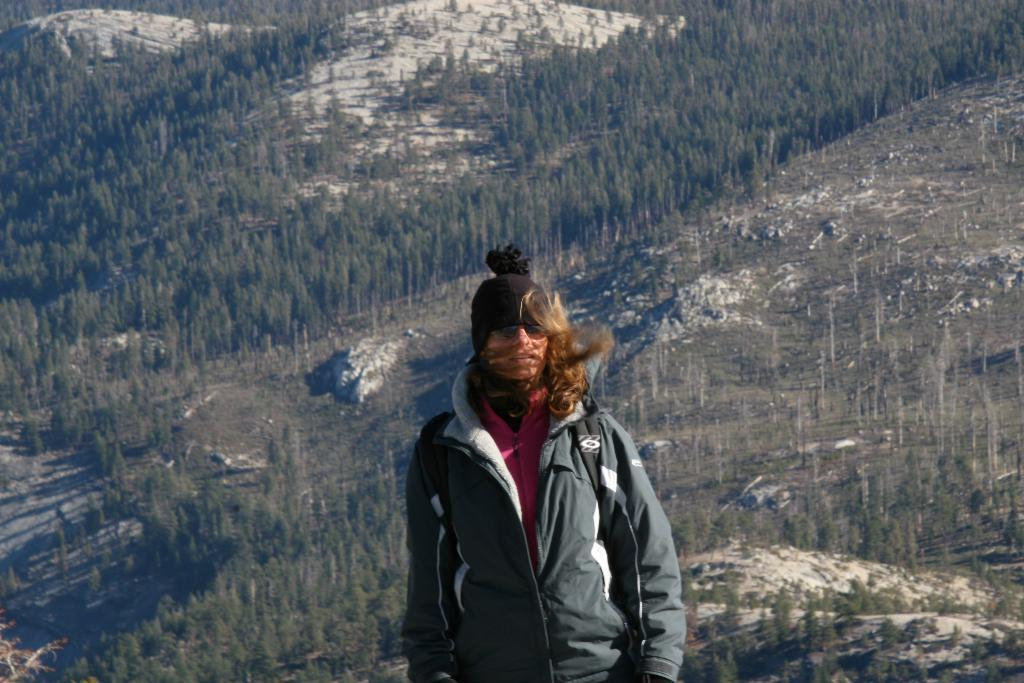Who is the main subject in the image? There is a lady in the center of the image. What is the lady wearing? The lady is wearing a coat and a cap. What can be seen in the background of the image? There are hills and trees visible in the background of the image. What type of balance exercise is the lady performing in the image? There is no indication in the image that the lady is performing any balance exercise. 